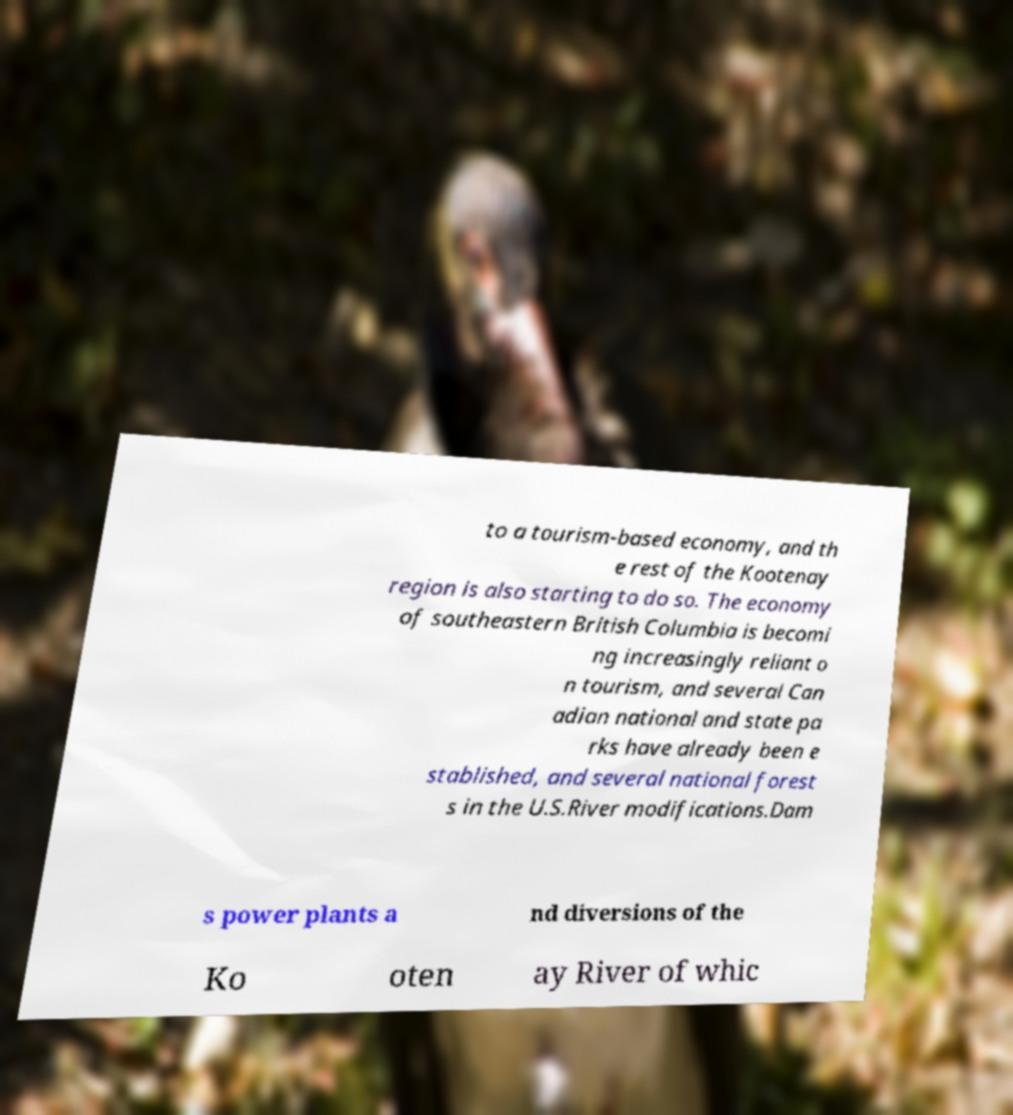Could you extract and type out the text from this image? to a tourism-based economy, and th e rest of the Kootenay region is also starting to do so. The economy of southeastern British Columbia is becomi ng increasingly reliant o n tourism, and several Can adian national and state pa rks have already been e stablished, and several national forest s in the U.S.River modifications.Dam s power plants a nd diversions of the Ko oten ay River of whic 